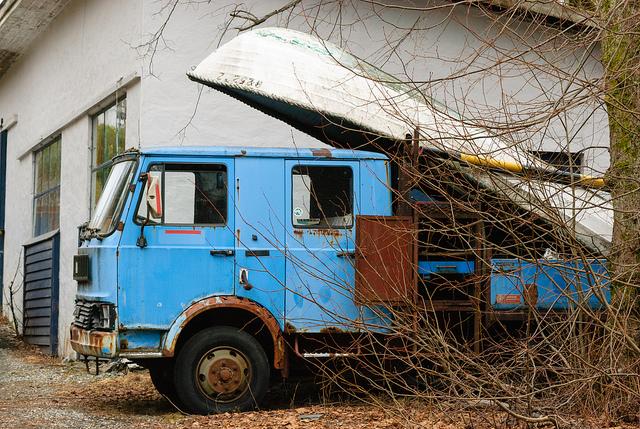Is there a silo above the truck?
Quick response, please. No. Is this a brand new truck?
Concise answer only. No. Is the truck rusted?
Write a very short answer. Yes. Does the truck have tires?
Be succinct. Yes. 